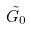<formula> <loc_0><loc_0><loc_500><loc_500>\tilde { G _ { 0 } }</formula> 